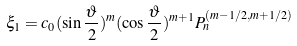<formula> <loc_0><loc_0><loc_500><loc_500>\xi _ { 1 } = c _ { 0 } ( \sin \frac { \vartheta } { 2 } ) ^ { m } ( \cos \frac { \vartheta } { 2 } ) ^ { m + 1 } P _ { n } ^ { ( m - 1 / 2 , m + 1 / 2 ) }</formula> 